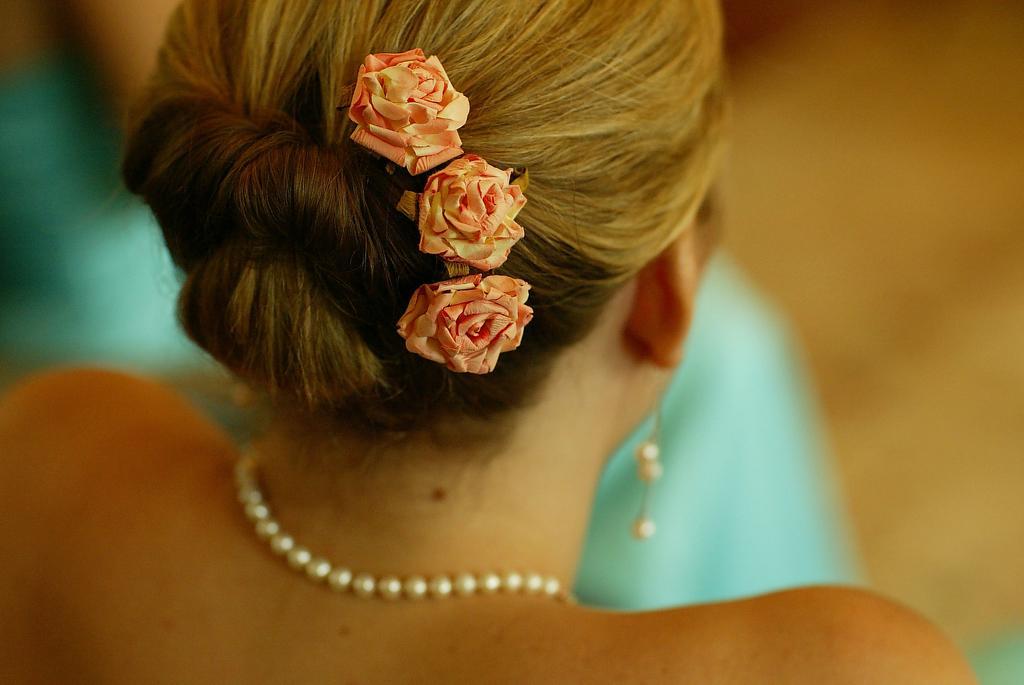Can you describe this image briefly? On the left side, there is a woman having three pink color rose flowers tied with hair, white color bead chain on her neck and a white color bead earring. And the background is blurred. 